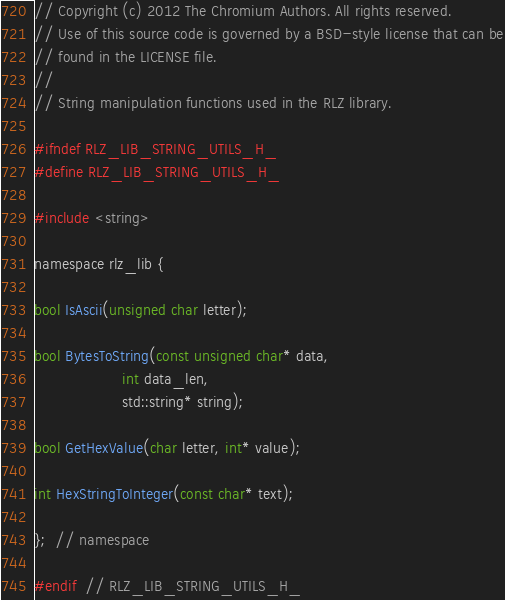<code> <loc_0><loc_0><loc_500><loc_500><_C_>// Copyright (c) 2012 The Chromium Authors. All rights reserved.
// Use of this source code is governed by a BSD-style license that can be
// found in the LICENSE file.
//
// String manipulation functions used in the RLZ library.

#ifndef RLZ_LIB_STRING_UTILS_H_
#define RLZ_LIB_STRING_UTILS_H_

#include <string>

namespace rlz_lib {

bool IsAscii(unsigned char letter);

bool BytesToString(const unsigned char* data,
                   int data_len,
                   std::string* string);

bool GetHexValue(char letter, int* value);

int HexStringToInteger(const char* text);

};  // namespace

#endif  // RLZ_LIB_STRING_UTILS_H_
</code> 